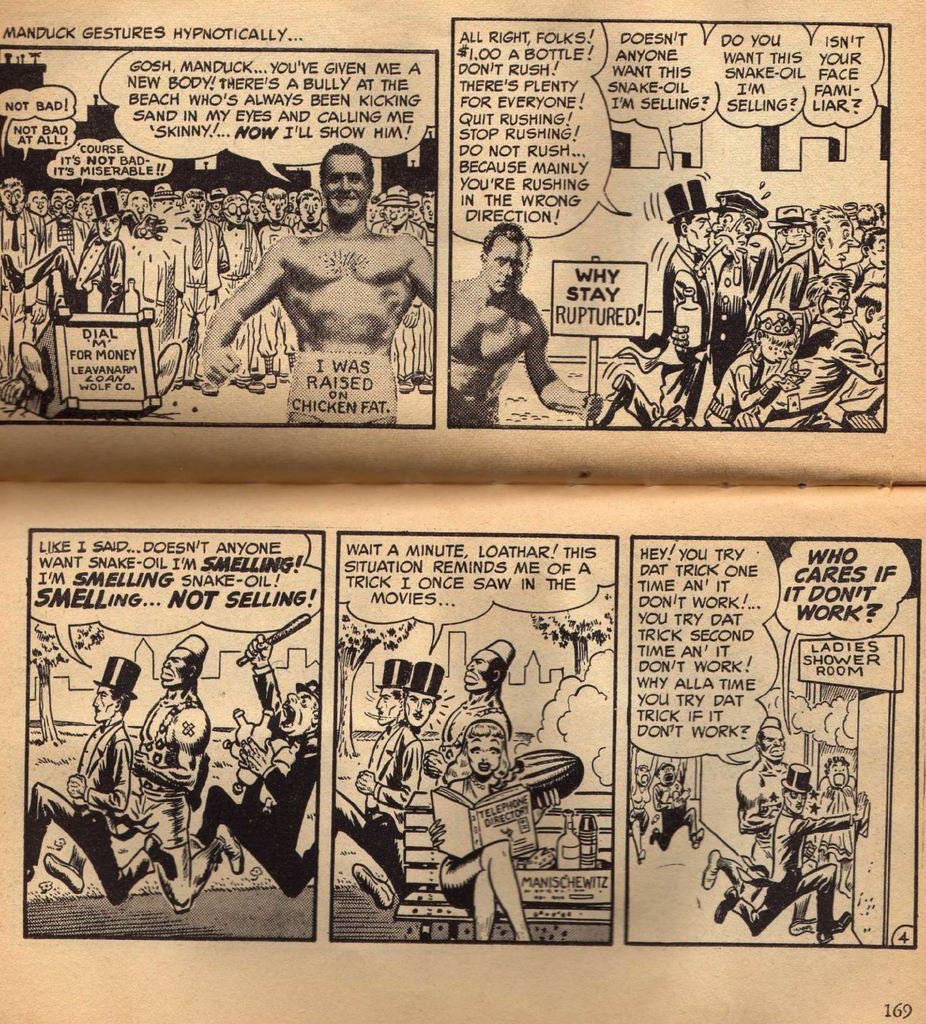<image>
Present a compact description of the photo's key features. An insert from a newspaper of a comic strip depicting Manduck Gestures Hypothetically. 